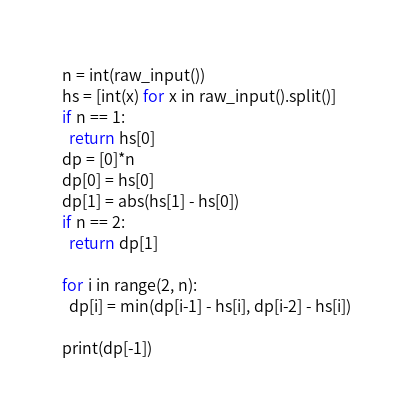<code> <loc_0><loc_0><loc_500><loc_500><_Python_>n = int(raw_input())
hs = [int(x) for x in raw_input().split()]
if n == 1:
  return hs[0]
dp = [0]*n
dp[0] = hs[0]
dp[1] = abs(hs[1] - hs[0])
if n == 2:
  return dp[1]

for i in range(2, n):
  dp[i] = min(dp[i-1] - hs[i], dp[i-2] - hs[i])

print(dp[-1])
</code> 